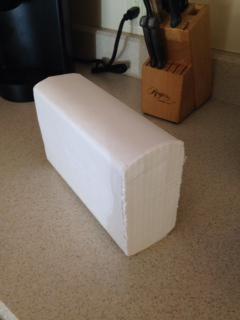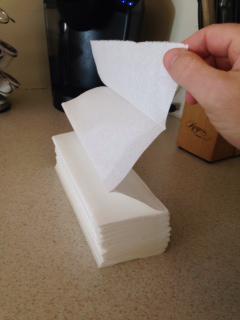The first image is the image on the left, the second image is the image on the right. Assess this claim about the two images: "A human hand is partially visible in the right image.". Correct or not? Answer yes or no. Yes. 